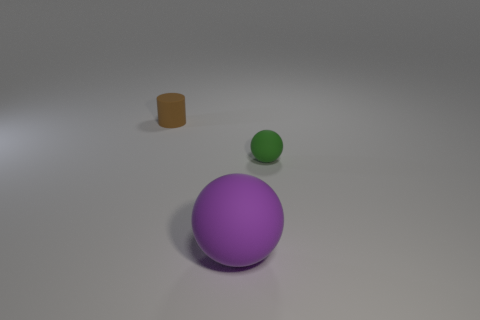There is a brown rubber object left of the small green ball; does it have the same size as the rubber sphere in front of the small green matte sphere?
Ensure brevity in your answer.  No. Are there an equal number of brown cylinders that are to the right of the tiny sphere and large purple things to the right of the purple matte thing?
Give a very brief answer. Yes. There is a green matte ball; is it the same size as the matte object that is on the left side of the large matte thing?
Your answer should be very brief. Yes. There is a matte thing on the right side of the purple sphere; are there any tiny green matte things to the left of it?
Keep it short and to the point. No. Are there any other things of the same shape as the tiny brown rubber thing?
Your answer should be very brief. No. How many brown things are on the right side of the object in front of the tiny matte thing that is to the right of the tiny cylinder?
Your answer should be compact. 0. How many things are small things in front of the tiny rubber cylinder or tiny green spheres right of the tiny brown cylinder?
Your response must be concise. 1. Is the number of tiny brown matte cylinders that are left of the small green sphere greater than the number of green matte things that are to the left of the brown rubber cylinder?
Make the answer very short. Yes. There is a small matte thing in front of the tiny cylinder; is it the same shape as the rubber thing that is behind the small sphere?
Make the answer very short. No. Are there any brown metallic blocks that have the same size as the brown matte cylinder?
Provide a succinct answer. No. 